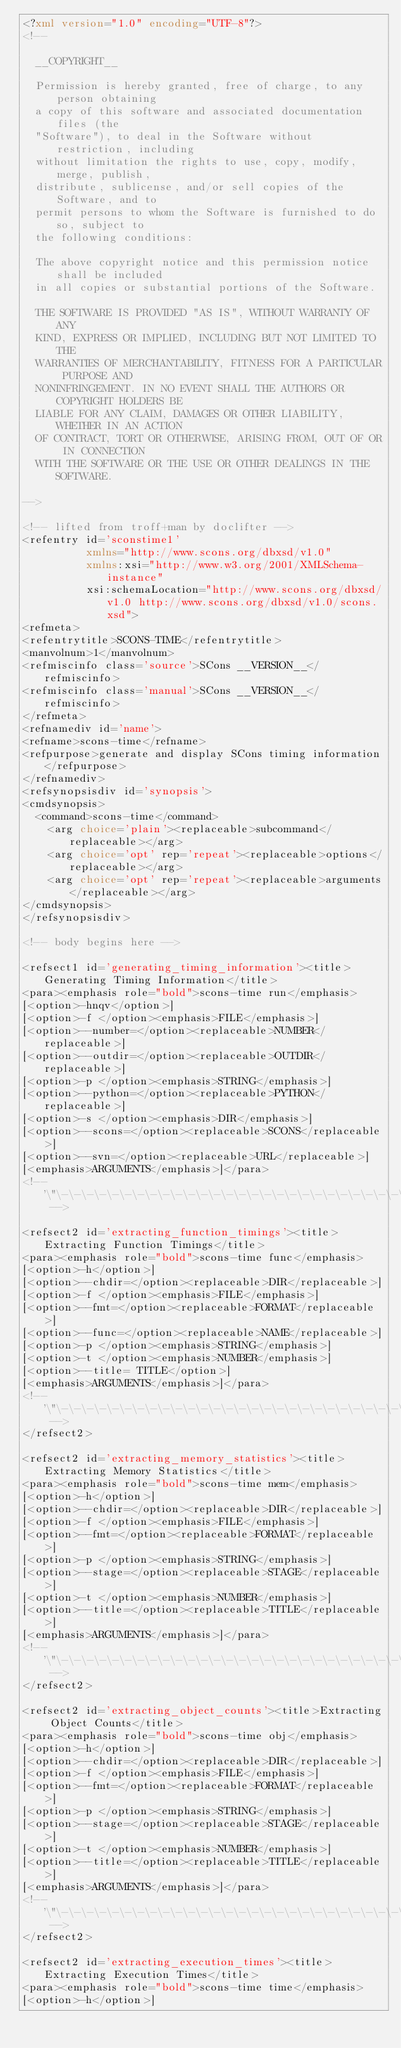Convert code to text. <code><loc_0><loc_0><loc_500><loc_500><_XML_><?xml version="1.0" encoding="UTF-8"?>
<!--

  __COPYRIGHT__

  Permission is hereby granted, free of charge, to any person obtaining
  a copy of this software and associated documentation files (the
  "Software"), to deal in the Software without restriction, including
  without limitation the rights to use, copy, modify, merge, publish,
  distribute, sublicense, and/or sell copies of the Software, and to
  permit persons to whom the Software is furnished to do so, subject to
  the following conditions:

  The above copyright notice and this permission notice shall be included
  in all copies or substantial portions of the Software.

  THE SOFTWARE IS PROVIDED "AS IS", WITHOUT WARRANTY OF ANY
  KIND, EXPRESS OR IMPLIED, INCLUDING BUT NOT LIMITED TO THE
  WARRANTIES OF MERCHANTABILITY, FITNESS FOR A PARTICULAR PURPOSE AND
  NONINFRINGEMENT. IN NO EVENT SHALL THE AUTHORS OR COPYRIGHT HOLDERS BE
  LIABLE FOR ANY CLAIM, DAMAGES OR OTHER LIABILITY, WHETHER IN AN ACTION
  OF CONTRACT, TORT OR OTHERWISE, ARISING FROM, OUT OF OR IN CONNECTION
  WITH THE SOFTWARE OR THE USE OR OTHER DEALINGS IN THE SOFTWARE.

-->

<!-- lifted from troff+man by doclifter -->
<refentry id='sconstime1'
          xmlns="http://www.scons.org/dbxsd/v1.0"
          xmlns:xsi="http://www.w3.org/2001/XMLSchema-instance"
          xsi:schemaLocation="http://www.scons.org/dbxsd/v1.0 http://www.scons.org/dbxsd/v1.0/scons.xsd">
<refmeta>
<refentrytitle>SCONS-TIME</refentrytitle>
<manvolnum>1</manvolnum>
<refmiscinfo class='source'>SCons __VERSION__</refmiscinfo>
<refmiscinfo class='manual'>SCons __VERSION__</refmiscinfo>
</refmeta>
<refnamediv id='name'>
<refname>scons-time</refname>
<refpurpose>generate and display SCons timing information</refpurpose>
</refnamediv>
<refsynopsisdiv id='synopsis'>
<cmdsynopsis>
  <command>scons-time</command>    
    <arg choice='plain'><replaceable>subcommand</replaceable></arg>
    <arg choice='opt' rep='repeat'><replaceable>options</replaceable></arg>
    <arg choice='opt' rep='repeat'><replaceable>arguments</replaceable></arg>
</cmdsynopsis>
</refsynopsisdiv>

<!-- body begins here -->

<refsect1 id='generating_timing_information'><title>Generating Timing Information</title>
<para><emphasis role="bold">scons-time run</emphasis>
[<option>-hnqv</option>]
[<option>-f </option><emphasis>FILE</emphasis>]
[<option>--number=</option><replaceable>NUMBER</replaceable>]
[<option>--outdir=</option><replaceable>OUTDIR</replaceable>]
[<option>-p </option><emphasis>STRING</emphasis>]
[<option>--python=</option><replaceable>PYTHON</replaceable>]
[<option>-s </option><emphasis>DIR</emphasis>]
[<option>--scons=</option><replaceable>SCONS</replaceable>]
[<option>--svn=</option><replaceable>URL</replaceable>]
[<emphasis>ARGUMENTS</emphasis>]</para>
<!-- '\"\-\-\-\-\-\-\-\-\-\-\-\-\-\-\-\-\-\-\-\-\-\-\-\-\-\-\-\-\-\-\-\-\-\-\-\-\-\-\-\-\-\-\-\-\-\-\-\-\-\-\-\-\-\-\-\-\-\-\-\-\-\-\-\-\-\-\-\-\-\-\-\-\-\- -->

<refsect2 id='extracting_function_timings'><title>Extracting Function Timings</title>
<para><emphasis role="bold">scons-time func</emphasis>
[<option>-h</option>]
[<option>--chdir=</option><replaceable>DIR</replaceable>]
[<option>-f </option><emphasis>FILE</emphasis>]
[<option>--fmt=</option><replaceable>FORMAT</replaceable>]
[<option>--func=</option><replaceable>NAME</replaceable>]
[<option>-p </option><emphasis>STRING</emphasis>]
[<option>-t </option><emphasis>NUMBER</emphasis>]
[<option>--title= TITLE</option>]
[<emphasis>ARGUMENTS</emphasis>]</para>
<!-- '\"\-\-\-\-\-\-\-\-\-\-\-\-\-\-\-\-\-\-\-\-\-\-\-\-\-\-\-\-\-\-\-\-\-\-\-\-\-\-\-\-\-\-\-\-\-\-\-\-\-\-\-\-\-\-\-\-\-\-\-\-\-\-\-\-\-\-\-\-\-\-\-\-\-\- -->
</refsect2>

<refsect2 id='extracting_memory_statistics'><title>Extracting Memory Statistics</title>
<para><emphasis role="bold">scons-time mem</emphasis>
[<option>-h</option>]
[<option>--chdir=</option><replaceable>DIR</replaceable>]
[<option>-f </option><emphasis>FILE</emphasis>]
[<option>--fmt=</option><replaceable>FORMAT</replaceable>]
[<option>-p </option><emphasis>STRING</emphasis>]
[<option>--stage=</option><replaceable>STAGE</replaceable>]
[<option>-t </option><emphasis>NUMBER</emphasis>]
[<option>--title=</option><replaceable>TITLE</replaceable>]
[<emphasis>ARGUMENTS</emphasis>]</para>
<!-- '\"\-\-\-\-\-\-\-\-\-\-\-\-\-\-\-\-\-\-\-\-\-\-\-\-\-\-\-\-\-\-\-\-\-\-\-\-\-\-\-\-\-\-\-\-\-\-\-\-\-\-\-\-\-\-\-\-\-\-\-\-\-\-\-\-\-\-\-\-\-\-\-\-\-\- -->
</refsect2>

<refsect2 id='extracting_object_counts'><title>Extracting Object Counts</title>
<para><emphasis role="bold">scons-time obj</emphasis>
[<option>-h</option>]
[<option>--chdir=</option><replaceable>DIR</replaceable>]
[<option>-f </option><emphasis>FILE</emphasis>]
[<option>--fmt=</option><replaceable>FORMAT</replaceable>]
[<option>-p </option><emphasis>STRING</emphasis>]
[<option>--stage=</option><replaceable>STAGE</replaceable>]
[<option>-t </option><emphasis>NUMBER</emphasis>]
[<option>--title=</option><replaceable>TITLE</replaceable>]
[<emphasis>ARGUMENTS</emphasis>]</para>
<!-- '\"\-\-\-\-\-\-\-\-\-\-\-\-\-\-\-\-\-\-\-\-\-\-\-\-\-\-\-\-\-\-\-\-\-\-\-\-\-\-\-\-\-\-\-\-\-\-\-\-\-\-\-\-\-\-\-\-\-\-\-\-\-\-\-\-\-\-\-\-\-\-\-\-\-\- -->
</refsect2>

<refsect2 id='extracting_execution_times'><title>Extracting Execution Times</title>
<para><emphasis role="bold">scons-time time</emphasis>
[<option>-h</option>]</code> 